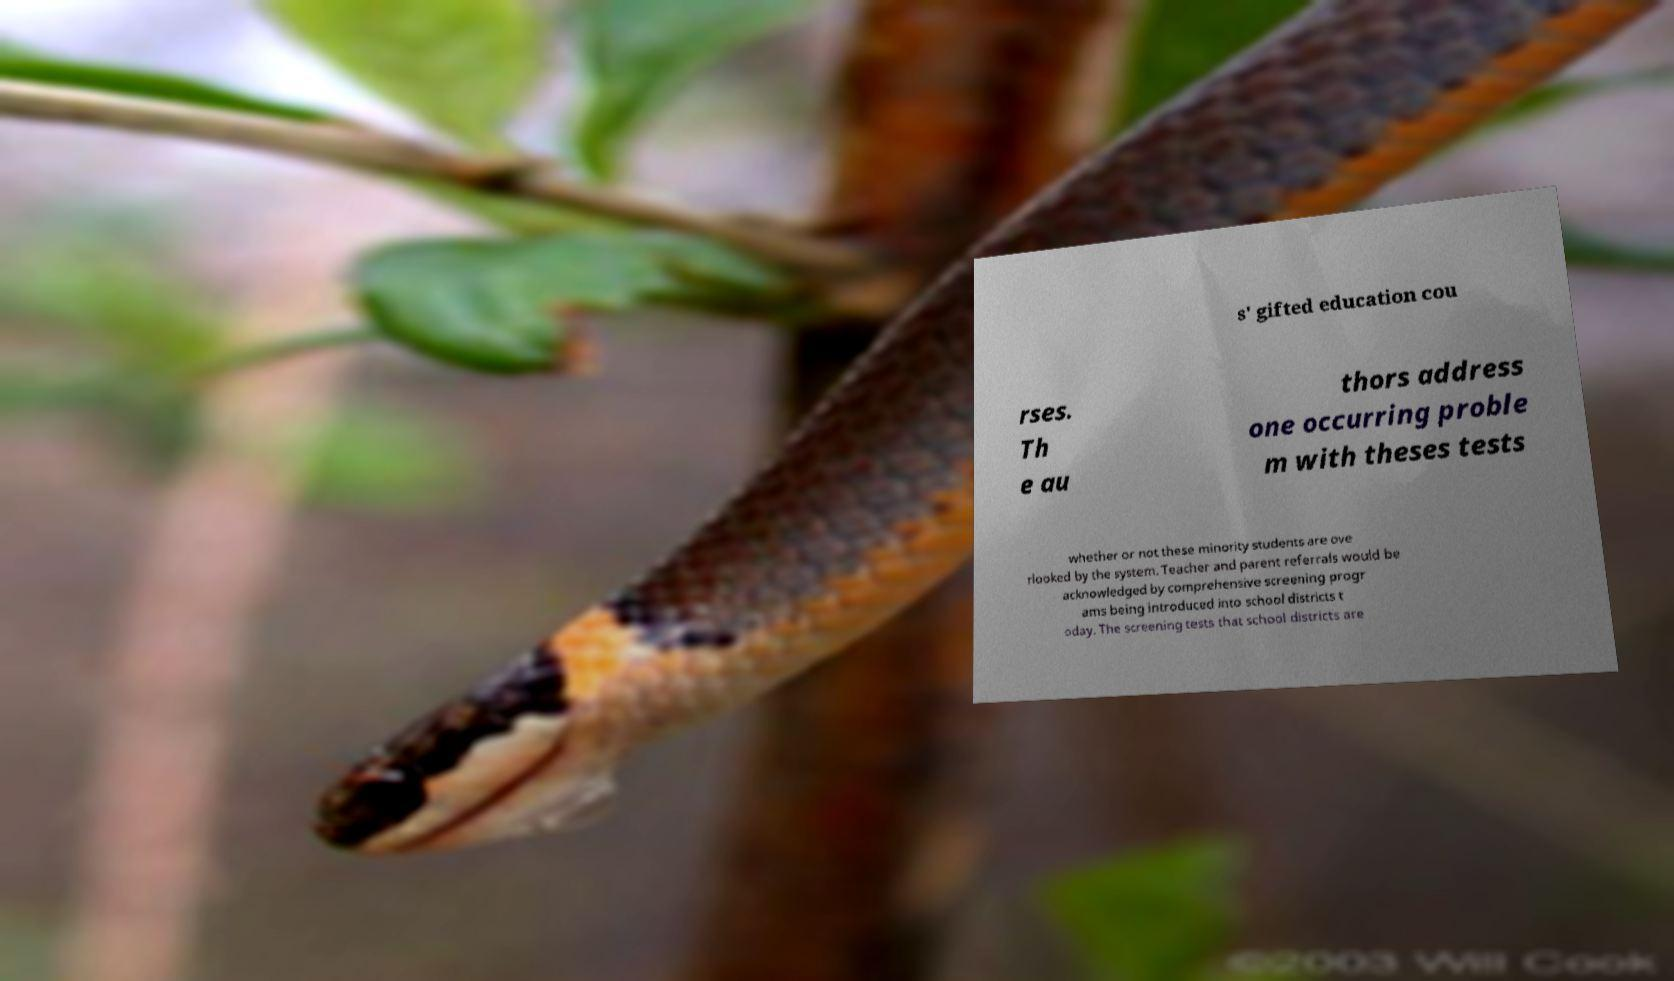Can you accurately transcribe the text from the provided image for me? s' gifted education cou rses. Th e au thors address one occurring proble m with theses tests whether or not these minority students are ove rlooked by the system. Teacher and parent referrals would be acknowledged by comprehensive screening progr ams being introduced into school districts t oday. The screening tests that school districts are 